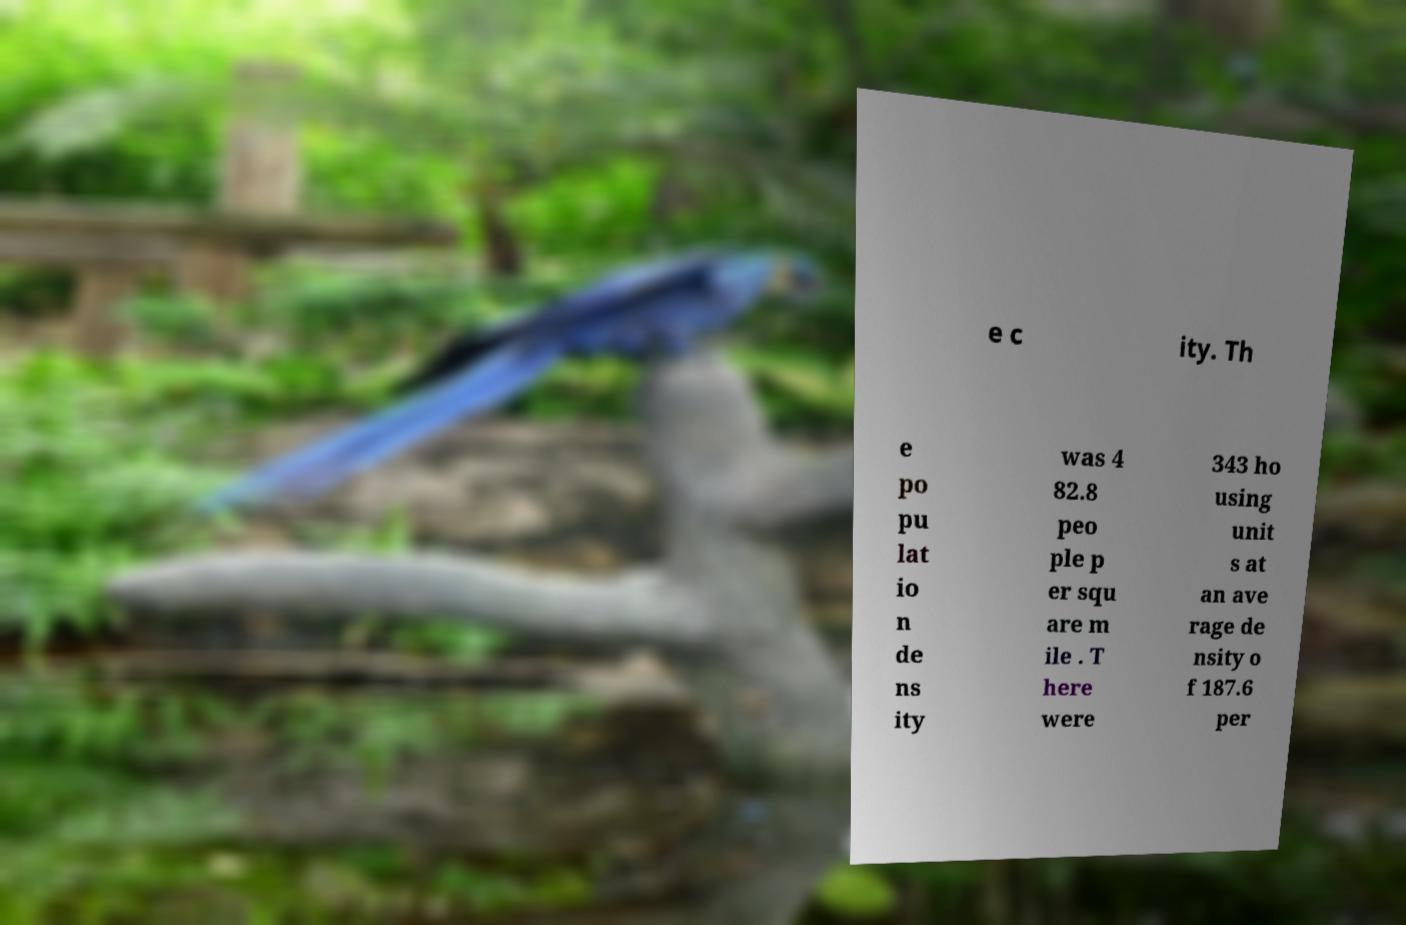Please read and relay the text visible in this image. What does it say? e c ity. Th e po pu lat io n de ns ity was 4 82.8 peo ple p er squ are m ile . T here were 343 ho using unit s at an ave rage de nsity o f 187.6 per 